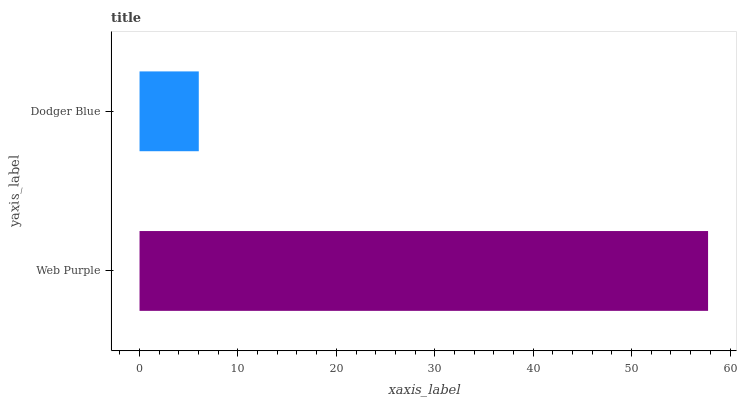Is Dodger Blue the minimum?
Answer yes or no. Yes. Is Web Purple the maximum?
Answer yes or no. Yes. Is Dodger Blue the maximum?
Answer yes or no. No. Is Web Purple greater than Dodger Blue?
Answer yes or no. Yes. Is Dodger Blue less than Web Purple?
Answer yes or no. Yes. Is Dodger Blue greater than Web Purple?
Answer yes or no. No. Is Web Purple less than Dodger Blue?
Answer yes or no. No. Is Web Purple the high median?
Answer yes or no. Yes. Is Dodger Blue the low median?
Answer yes or no. Yes. Is Dodger Blue the high median?
Answer yes or no. No. Is Web Purple the low median?
Answer yes or no. No. 